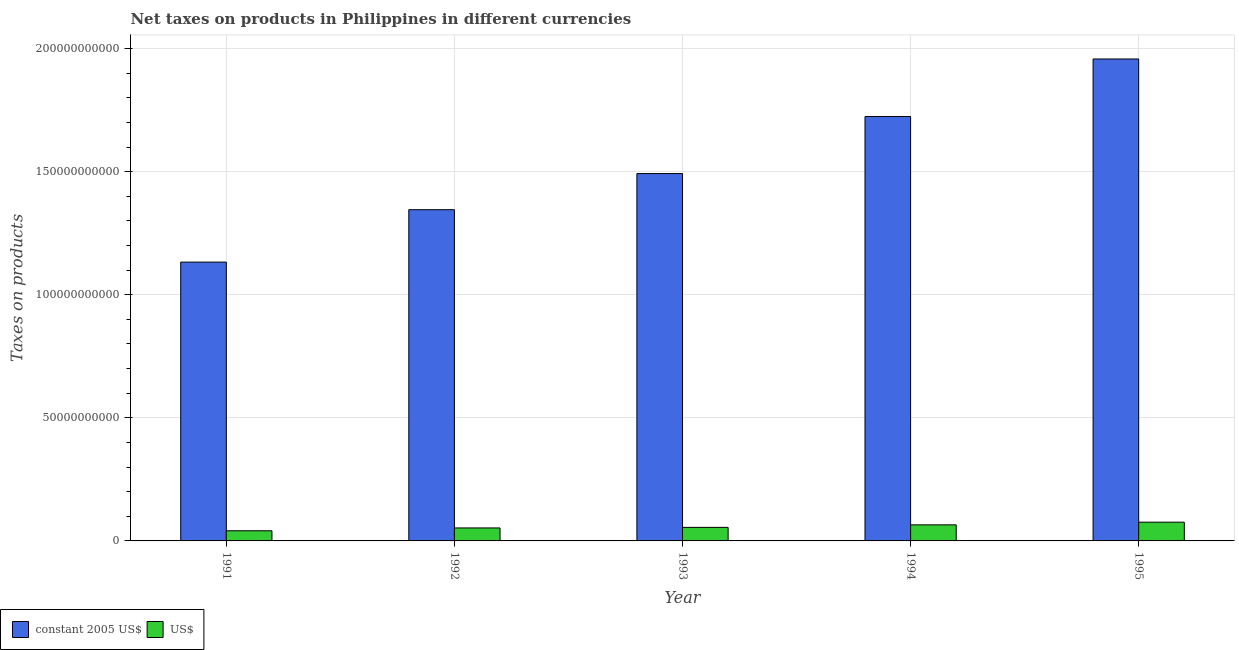How many different coloured bars are there?
Provide a short and direct response. 2. How many groups of bars are there?
Offer a terse response. 5. Are the number of bars per tick equal to the number of legend labels?
Offer a very short reply. Yes. Are the number of bars on each tick of the X-axis equal?
Provide a short and direct response. Yes. How many bars are there on the 4th tick from the left?
Give a very brief answer. 2. What is the net taxes in constant 2005 us$ in 1992?
Make the answer very short. 1.35e+11. Across all years, what is the maximum net taxes in constant 2005 us$?
Provide a short and direct response. 1.96e+11. Across all years, what is the minimum net taxes in us$?
Offer a terse response. 4.12e+09. In which year was the net taxes in constant 2005 us$ maximum?
Make the answer very short. 1995. What is the total net taxes in constant 2005 us$ in the graph?
Your response must be concise. 7.65e+11. What is the difference between the net taxes in constant 2005 us$ in 1994 and that in 1995?
Provide a short and direct response. -2.34e+1. What is the difference between the net taxes in constant 2005 us$ in 1991 and the net taxes in us$ in 1992?
Your answer should be compact. -2.13e+1. What is the average net taxes in us$ per year?
Keep it short and to the point. 5.81e+09. In the year 1995, what is the difference between the net taxes in us$ and net taxes in constant 2005 us$?
Give a very brief answer. 0. In how many years, is the net taxes in us$ greater than 80000000000 units?
Provide a succinct answer. 0. What is the ratio of the net taxes in us$ in 1993 to that in 1995?
Make the answer very short. 0.72. Is the net taxes in constant 2005 us$ in 1991 less than that in 1992?
Ensure brevity in your answer.  Yes. Is the difference between the net taxes in us$ in 1992 and 1993 greater than the difference between the net taxes in constant 2005 us$ in 1992 and 1993?
Your response must be concise. No. What is the difference between the highest and the second highest net taxes in constant 2005 us$?
Make the answer very short. 2.34e+1. What is the difference between the highest and the lowest net taxes in constant 2005 us$?
Your response must be concise. 8.25e+1. Is the sum of the net taxes in constant 2005 us$ in 1994 and 1995 greater than the maximum net taxes in us$ across all years?
Make the answer very short. Yes. What does the 2nd bar from the left in 1991 represents?
Your answer should be compact. US$. What does the 1st bar from the right in 1991 represents?
Your answer should be very brief. US$. Are all the bars in the graph horizontal?
Ensure brevity in your answer.  No. What is the difference between two consecutive major ticks on the Y-axis?
Your response must be concise. 5.00e+1. Does the graph contain any zero values?
Provide a short and direct response. No. Does the graph contain grids?
Your response must be concise. Yes. What is the title of the graph?
Your answer should be compact. Net taxes on products in Philippines in different currencies. Does "Death rate" appear as one of the legend labels in the graph?
Your response must be concise. No. What is the label or title of the Y-axis?
Your answer should be very brief. Taxes on products. What is the Taxes on products of constant 2005 US$ in 1991?
Your answer should be compact. 1.13e+11. What is the Taxes on products in US$ in 1991?
Provide a short and direct response. 4.12e+09. What is the Taxes on products of constant 2005 US$ in 1992?
Your answer should be very brief. 1.35e+11. What is the Taxes on products in US$ in 1992?
Ensure brevity in your answer.  5.27e+09. What is the Taxes on products of constant 2005 US$ in 1993?
Your answer should be compact. 1.49e+11. What is the Taxes on products of US$ in 1993?
Your response must be concise. 5.50e+09. What is the Taxes on products of constant 2005 US$ in 1994?
Offer a terse response. 1.72e+11. What is the Taxes on products in US$ in 1994?
Give a very brief answer. 6.53e+09. What is the Taxes on products in constant 2005 US$ in 1995?
Give a very brief answer. 1.96e+11. What is the Taxes on products in US$ in 1995?
Make the answer very short. 7.61e+09. Across all years, what is the maximum Taxes on products in constant 2005 US$?
Your answer should be compact. 1.96e+11. Across all years, what is the maximum Taxes on products in US$?
Offer a very short reply. 7.61e+09. Across all years, what is the minimum Taxes on products of constant 2005 US$?
Your answer should be very brief. 1.13e+11. Across all years, what is the minimum Taxes on products in US$?
Give a very brief answer. 4.12e+09. What is the total Taxes on products in constant 2005 US$ in the graph?
Make the answer very short. 7.65e+11. What is the total Taxes on products of US$ in the graph?
Offer a very short reply. 2.90e+1. What is the difference between the Taxes on products of constant 2005 US$ in 1991 and that in 1992?
Keep it short and to the point. -2.13e+1. What is the difference between the Taxes on products of US$ in 1991 and that in 1992?
Your answer should be very brief. -1.15e+09. What is the difference between the Taxes on products in constant 2005 US$ in 1991 and that in 1993?
Provide a succinct answer. -3.60e+1. What is the difference between the Taxes on products in US$ in 1991 and that in 1993?
Make the answer very short. -1.38e+09. What is the difference between the Taxes on products of constant 2005 US$ in 1991 and that in 1994?
Your answer should be compact. -5.91e+1. What is the difference between the Taxes on products of US$ in 1991 and that in 1994?
Provide a succinct answer. -2.40e+09. What is the difference between the Taxes on products of constant 2005 US$ in 1991 and that in 1995?
Your answer should be very brief. -8.25e+1. What is the difference between the Taxes on products in US$ in 1991 and that in 1995?
Keep it short and to the point. -3.49e+09. What is the difference between the Taxes on products of constant 2005 US$ in 1992 and that in 1993?
Provide a succinct answer. -1.47e+1. What is the difference between the Taxes on products in US$ in 1992 and that in 1993?
Make the answer very short. -2.29e+08. What is the difference between the Taxes on products of constant 2005 US$ in 1992 and that in 1994?
Offer a terse response. -3.79e+1. What is the difference between the Taxes on products of US$ in 1992 and that in 1994?
Provide a short and direct response. -1.25e+09. What is the difference between the Taxes on products of constant 2005 US$ in 1992 and that in 1995?
Your response must be concise. -6.12e+1. What is the difference between the Taxes on products in US$ in 1992 and that in 1995?
Your response must be concise. -2.34e+09. What is the difference between the Taxes on products in constant 2005 US$ in 1993 and that in 1994?
Your answer should be compact. -2.32e+1. What is the difference between the Taxes on products of US$ in 1993 and that in 1994?
Offer a terse response. -1.02e+09. What is the difference between the Taxes on products of constant 2005 US$ in 1993 and that in 1995?
Make the answer very short. -4.65e+1. What is the difference between the Taxes on products in US$ in 1993 and that in 1995?
Your answer should be compact. -2.11e+09. What is the difference between the Taxes on products of constant 2005 US$ in 1994 and that in 1995?
Make the answer very short. -2.34e+1. What is the difference between the Taxes on products in US$ in 1994 and that in 1995?
Your response must be concise. -1.09e+09. What is the difference between the Taxes on products of constant 2005 US$ in 1991 and the Taxes on products of US$ in 1992?
Offer a terse response. 1.08e+11. What is the difference between the Taxes on products of constant 2005 US$ in 1991 and the Taxes on products of US$ in 1993?
Provide a short and direct response. 1.08e+11. What is the difference between the Taxes on products in constant 2005 US$ in 1991 and the Taxes on products in US$ in 1994?
Your answer should be very brief. 1.07e+11. What is the difference between the Taxes on products in constant 2005 US$ in 1991 and the Taxes on products in US$ in 1995?
Provide a succinct answer. 1.06e+11. What is the difference between the Taxes on products of constant 2005 US$ in 1992 and the Taxes on products of US$ in 1993?
Offer a terse response. 1.29e+11. What is the difference between the Taxes on products in constant 2005 US$ in 1992 and the Taxes on products in US$ in 1994?
Provide a short and direct response. 1.28e+11. What is the difference between the Taxes on products in constant 2005 US$ in 1992 and the Taxes on products in US$ in 1995?
Keep it short and to the point. 1.27e+11. What is the difference between the Taxes on products of constant 2005 US$ in 1993 and the Taxes on products of US$ in 1994?
Keep it short and to the point. 1.43e+11. What is the difference between the Taxes on products in constant 2005 US$ in 1993 and the Taxes on products in US$ in 1995?
Give a very brief answer. 1.42e+11. What is the difference between the Taxes on products in constant 2005 US$ in 1994 and the Taxes on products in US$ in 1995?
Make the answer very short. 1.65e+11. What is the average Taxes on products in constant 2005 US$ per year?
Provide a short and direct response. 1.53e+11. What is the average Taxes on products in US$ per year?
Your answer should be compact. 5.81e+09. In the year 1991, what is the difference between the Taxes on products of constant 2005 US$ and Taxes on products of US$?
Your answer should be very brief. 1.09e+11. In the year 1992, what is the difference between the Taxes on products of constant 2005 US$ and Taxes on products of US$?
Provide a succinct answer. 1.29e+11. In the year 1993, what is the difference between the Taxes on products in constant 2005 US$ and Taxes on products in US$?
Your answer should be compact. 1.44e+11. In the year 1994, what is the difference between the Taxes on products in constant 2005 US$ and Taxes on products in US$?
Provide a short and direct response. 1.66e+11. In the year 1995, what is the difference between the Taxes on products in constant 2005 US$ and Taxes on products in US$?
Your answer should be very brief. 1.88e+11. What is the ratio of the Taxes on products in constant 2005 US$ in 1991 to that in 1992?
Offer a very short reply. 0.84. What is the ratio of the Taxes on products in US$ in 1991 to that in 1992?
Your answer should be very brief. 0.78. What is the ratio of the Taxes on products of constant 2005 US$ in 1991 to that in 1993?
Your answer should be very brief. 0.76. What is the ratio of the Taxes on products in US$ in 1991 to that in 1993?
Your answer should be very brief. 0.75. What is the ratio of the Taxes on products in constant 2005 US$ in 1991 to that in 1994?
Your response must be concise. 0.66. What is the ratio of the Taxes on products in US$ in 1991 to that in 1994?
Provide a short and direct response. 0.63. What is the ratio of the Taxes on products in constant 2005 US$ in 1991 to that in 1995?
Offer a terse response. 0.58. What is the ratio of the Taxes on products of US$ in 1991 to that in 1995?
Provide a short and direct response. 0.54. What is the ratio of the Taxes on products of constant 2005 US$ in 1992 to that in 1993?
Provide a succinct answer. 0.9. What is the ratio of the Taxes on products of US$ in 1992 to that in 1993?
Offer a terse response. 0.96. What is the ratio of the Taxes on products in constant 2005 US$ in 1992 to that in 1994?
Offer a very short reply. 0.78. What is the ratio of the Taxes on products of US$ in 1992 to that in 1994?
Your answer should be compact. 0.81. What is the ratio of the Taxes on products of constant 2005 US$ in 1992 to that in 1995?
Provide a succinct answer. 0.69. What is the ratio of the Taxes on products of US$ in 1992 to that in 1995?
Ensure brevity in your answer.  0.69. What is the ratio of the Taxes on products in constant 2005 US$ in 1993 to that in 1994?
Provide a short and direct response. 0.87. What is the ratio of the Taxes on products of US$ in 1993 to that in 1994?
Give a very brief answer. 0.84. What is the ratio of the Taxes on products of constant 2005 US$ in 1993 to that in 1995?
Your answer should be very brief. 0.76. What is the ratio of the Taxes on products of US$ in 1993 to that in 1995?
Your answer should be very brief. 0.72. What is the ratio of the Taxes on products of constant 2005 US$ in 1994 to that in 1995?
Provide a succinct answer. 0.88. What is the ratio of the Taxes on products in US$ in 1994 to that in 1995?
Your answer should be very brief. 0.86. What is the difference between the highest and the second highest Taxes on products of constant 2005 US$?
Your response must be concise. 2.34e+1. What is the difference between the highest and the second highest Taxes on products in US$?
Offer a terse response. 1.09e+09. What is the difference between the highest and the lowest Taxes on products in constant 2005 US$?
Your response must be concise. 8.25e+1. What is the difference between the highest and the lowest Taxes on products in US$?
Ensure brevity in your answer.  3.49e+09. 